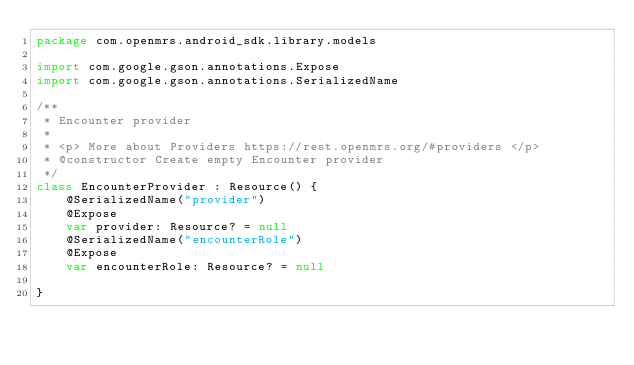Convert code to text. <code><loc_0><loc_0><loc_500><loc_500><_Kotlin_>package com.openmrs.android_sdk.library.models

import com.google.gson.annotations.Expose
import com.google.gson.annotations.SerializedName

/**
 * Encounter provider
 *
 * <p> More about Providers https://rest.openmrs.org/#providers </p>
 * @constructor Create empty Encounter provider
 */
class EncounterProvider : Resource() {
    @SerializedName("provider")
    @Expose
    var provider: Resource? = null
    @SerializedName("encounterRole")
    @Expose
    var encounterRole: Resource? = null

}</code> 